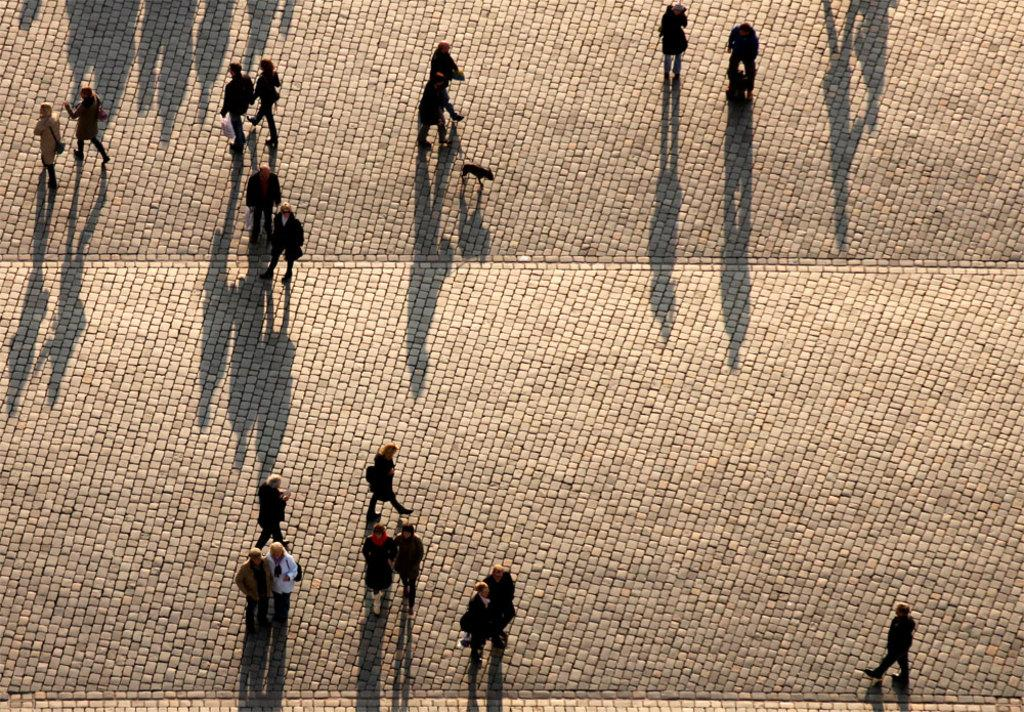What perspective is the image taken from? The image is taken from a top view. What types of activities are the people in the image engaged in? Some people are walking, and some people are standing. Can you describe the animal in the image? Unfortunately, the facts provided do not give any information about the animal in the image. What type of war is depicted in the image? There is no war depicted in the image; it features people walking and standing from a top view. What type of building is visible in the image? The facts provided do not mention any buildings in the image. 